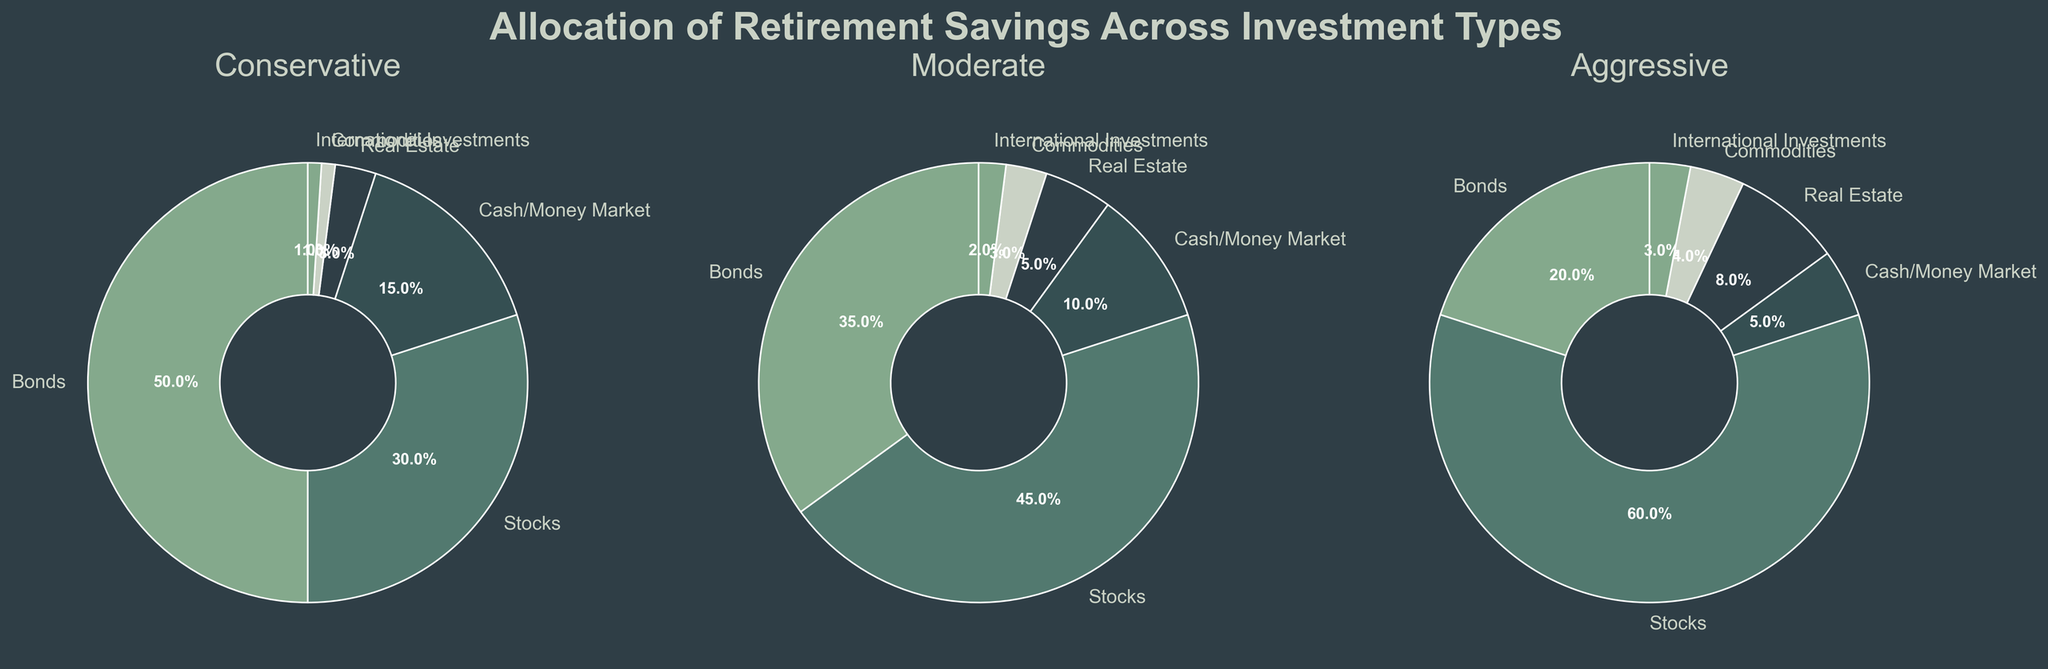What percentage of retirement savings is allocated to bonds in a conservative investment strategy? Look at the 'Conservative' pie chart and find the segment labeled 'Bonds'. The percentage indicated on that segment is the allocation.
Answer: 50% Which investment type has the highest allocation in an aggressive investment strategy? Refer to the 'Aggressive' pie chart and identify which segment has the largest visual size or the highest percentage label.
Answer: Stocks What is the difference in allocation to cash/money market between conservative and aggressive strategies? Find the percentage for cash/money market in both 'Conservative' and 'Aggressive' pie charts. Subtract the smaller percentage from the larger percentage.
Answer: 10% Compare the allocation to real estate in moderate and aggressive strategies; which one has a higher percentage? Look at the 'Moderate' and 'Aggressive' pie charts, read the percentages for real estate, and compare them.
Answer: Aggressive What is the combined allocation to commodities and international investments in a moderate strategy? Identify the percentages for commodities and international investments in the 'Moderate' pie chart and sum them up.
Answer: 5% In which investment strategy does the allocation to stocks exceed 40%? Examine each of the pie charts (Conservative, Moderate, Aggressive) and find where the percentage for stocks is greater than 40%.
Answer: Moderate, Aggressive What is the total allocation to bonds, cash/money market, and real estate in a conservative investment strategy? Add up the percentages for bonds, cash/money market, and real estate in the 'Conservative' pie chart.
Answer: 68% 